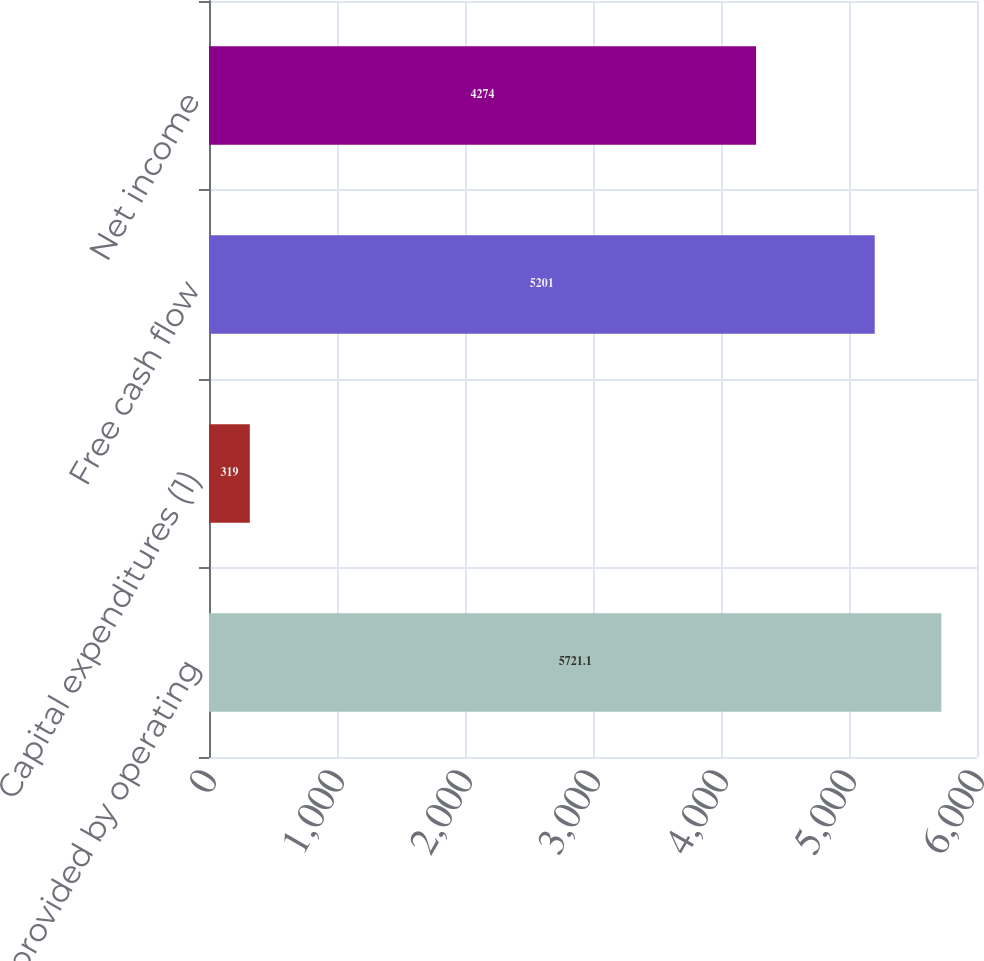Convert chart to OTSL. <chart><loc_0><loc_0><loc_500><loc_500><bar_chart><fcel>Cash provided by operating<fcel>Capital expenditures (1)<fcel>Free cash flow<fcel>Net income<nl><fcel>5721.1<fcel>319<fcel>5201<fcel>4274<nl></chart> 